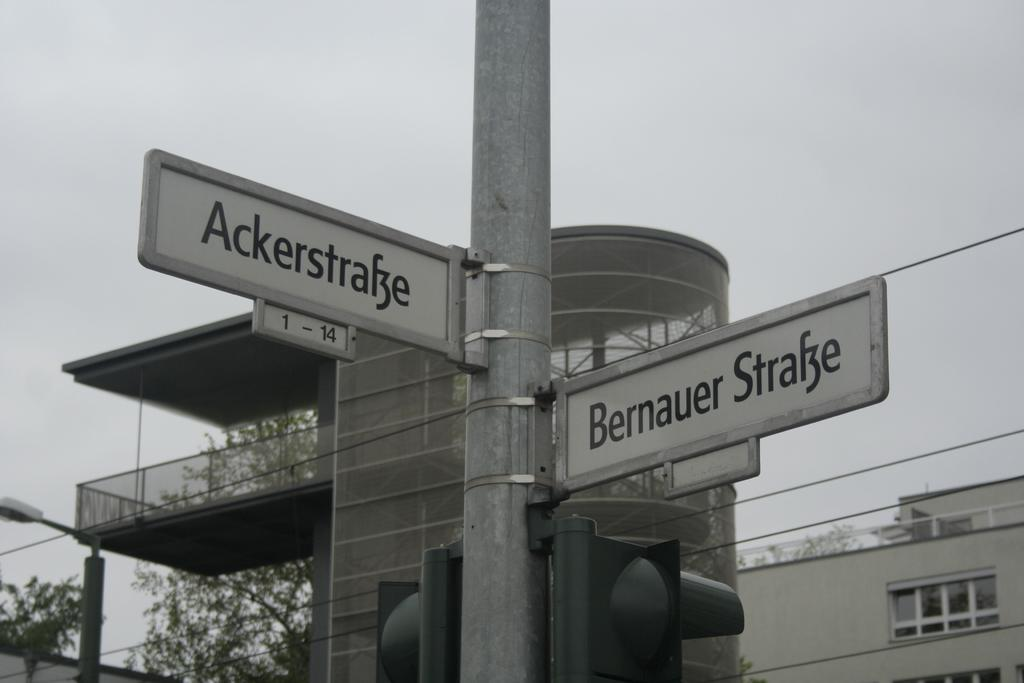<image>
Present a compact description of the photo's key features. the street name outside which is Bernaur strake 